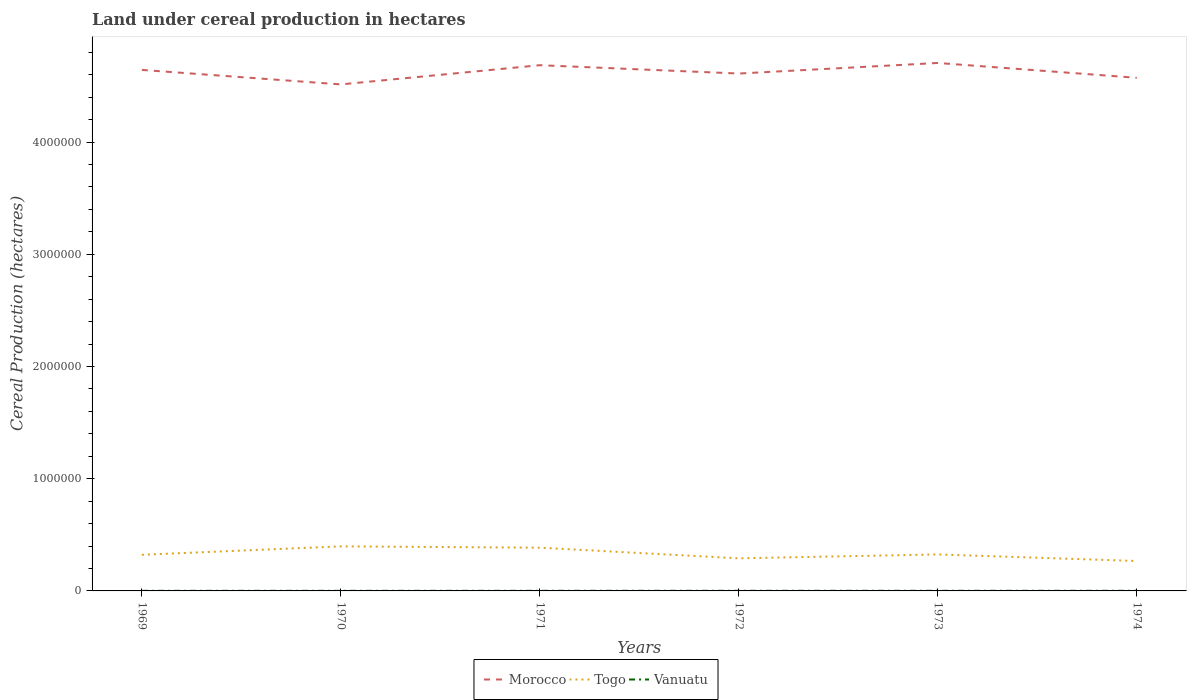How many different coloured lines are there?
Your answer should be compact. 3. Is the number of lines equal to the number of legend labels?
Keep it short and to the point. Yes. Across all years, what is the maximum land under cereal production in Togo?
Provide a succinct answer. 2.67e+05. In which year was the land under cereal production in Morocco maximum?
Keep it short and to the point. 1970. What is the total land under cereal production in Vanuatu in the graph?
Provide a succinct answer. -100. What is the difference between the highest and the second highest land under cereal production in Vanuatu?
Make the answer very short. 200. What is the difference between the highest and the lowest land under cereal production in Togo?
Offer a terse response. 2. What is the difference between two consecutive major ticks on the Y-axis?
Give a very brief answer. 1.00e+06. Are the values on the major ticks of Y-axis written in scientific E-notation?
Offer a very short reply. No. Does the graph contain any zero values?
Your answer should be compact. No. Does the graph contain grids?
Give a very brief answer. No. What is the title of the graph?
Ensure brevity in your answer.  Land under cereal production in hectares. Does "St. Martin (French part)" appear as one of the legend labels in the graph?
Offer a very short reply. No. What is the label or title of the X-axis?
Your answer should be compact. Years. What is the label or title of the Y-axis?
Offer a terse response. Cereal Production (hectares). What is the Cereal Production (hectares) in Morocco in 1969?
Give a very brief answer. 4.64e+06. What is the Cereal Production (hectares) of Togo in 1969?
Keep it short and to the point. 3.22e+05. What is the Cereal Production (hectares) of Vanuatu in 1969?
Offer a terse response. 800. What is the Cereal Production (hectares) of Morocco in 1970?
Keep it short and to the point. 4.51e+06. What is the Cereal Production (hectares) in Togo in 1970?
Your answer should be compact. 3.97e+05. What is the Cereal Production (hectares) of Vanuatu in 1970?
Your answer should be compact. 850. What is the Cereal Production (hectares) of Morocco in 1971?
Provide a succinct answer. 4.68e+06. What is the Cereal Production (hectares) of Togo in 1971?
Offer a very short reply. 3.85e+05. What is the Cereal Production (hectares) in Vanuatu in 1971?
Your answer should be very brief. 900. What is the Cereal Production (hectares) of Morocco in 1972?
Keep it short and to the point. 4.61e+06. What is the Cereal Production (hectares) of Togo in 1972?
Keep it short and to the point. 2.90e+05. What is the Cereal Production (hectares) of Vanuatu in 1972?
Provide a short and direct response. 950. What is the Cereal Production (hectares) in Morocco in 1973?
Your answer should be compact. 4.70e+06. What is the Cereal Production (hectares) of Togo in 1973?
Offer a very short reply. 3.25e+05. What is the Cereal Production (hectares) in Vanuatu in 1973?
Offer a terse response. 1000. What is the Cereal Production (hectares) in Morocco in 1974?
Offer a terse response. 4.57e+06. What is the Cereal Production (hectares) of Togo in 1974?
Provide a succinct answer. 2.67e+05. What is the Cereal Production (hectares) of Vanuatu in 1974?
Your answer should be very brief. 1000. Across all years, what is the maximum Cereal Production (hectares) in Morocco?
Your response must be concise. 4.70e+06. Across all years, what is the maximum Cereal Production (hectares) of Togo?
Offer a very short reply. 3.97e+05. Across all years, what is the maximum Cereal Production (hectares) in Vanuatu?
Your answer should be very brief. 1000. Across all years, what is the minimum Cereal Production (hectares) in Morocco?
Provide a succinct answer. 4.51e+06. Across all years, what is the minimum Cereal Production (hectares) of Togo?
Ensure brevity in your answer.  2.67e+05. Across all years, what is the minimum Cereal Production (hectares) in Vanuatu?
Make the answer very short. 800. What is the total Cereal Production (hectares) of Morocco in the graph?
Provide a succinct answer. 2.77e+07. What is the total Cereal Production (hectares) of Togo in the graph?
Your answer should be compact. 1.99e+06. What is the total Cereal Production (hectares) of Vanuatu in the graph?
Your response must be concise. 5500. What is the difference between the Cereal Production (hectares) of Morocco in 1969 and that in 1970?
Your answer should be compact. 1.29e+05. What is the difference between the Cereal Production (hectares) of Togo in 1969 and that in 1970?
Your answer should be compact. -7.50e+04. What is the difference between the Cereal Production (hectares) in Vanuatu in 1969 and that in 1970?
Provide a succinct answer. -50. What is the difference between the Cereal Production (hectares) in Morocco in 1969 and that in 1971?
Offer a terse response. -4.19e+04. What is the difference between the Cereal Production (hectares) of Togo in 1969 and that in 1971?
Give a very brief answer. -6.33e+04. What is the difference between the Cereal Production (hectares) of Vanuatu in 1969 and that in 1971?
Provide a short and direct response. -100. What is the difference between the Cereal Production (hectares) of Morocco in 1969 and that in 1972?
Provide a succinct answer. 3.23e+04. What is the difference between the Cereal Production (hectares) in Togo in 1969 and that in 1972?
Make the answer very short. 3.15e+04. What is the difference between the Cereal Production (hectares) in Vanuatu in 1969 and that in 1972?
Keep it short and to the point. -150. What is the difference between the Cereal Production (hectares) in Morocco in 1969 and that in 1973?
Offer a very short reply. -6.18e+04. What is the difference between the Cereal Production (hectares) of Togo in 1969 and that in 1973?
Offer a very short reply. -3030. What is the difference between the Cereal Production (hectares) in Vanuatu in 1969 and that in 1973?
Provide a succinct answer. -200. What is the difference between the Cereal Production (hectares) of Morocco in 1969 and that in 1974?
Offer a terse response. 7.04e+04. What is the difference between the Cereal Production (hectares) of Togo in 1969 and that in 1974?
Provide a succinct answer. 5.53e+04. What is the difference between the Cereal Production (hectares) in Vanuatu in 1969 and that in 1974?
Provide a succinct answer. -200. What is the difference between the Cereal Production (hectares) of Morocco in 1970 and that in 1971?
Give a very brief answer. -1.71e+05. What is the difference between the Cereal Production (hectares) in Togo in 1970 and that in 1971?
Offer a very short reply. 1.17e+04. What is the difference between the Cereal Production (hectares) in Vanuatu in 1970 and that in 1971?
Provide a succinct answer. -50. What is the difference between the Cereal Production (hectares) of Morocco in 1970 and that in 1972?
Provide a short and direct response. -9.69e+04. What is the difference between the Cereal Production (hectares) in Togo in 1970 and that in 1972?
Make the answer very short. 1.07e+05. What is the difference between the Cereal Production (hectares) in Vanuatu in 1970 and that in 1972?
Your answer should be very brief. -100. What is the difference between the Cereal Production (hectares) of Morocco in 1970 and that in 1973?
Keep it short and to the point. -1.91e+05. What is the difference between the Cereal Production (hectares) of Togo in 1970 and that in 1973?
Offer a very short reply. 7.20e+04. What is the difference between the Cereal Production (hectares) of Vanuatu in 1970 and that in 1973?
Give a very brief answer. -150. What is the difference between the Cereal Production (hectares) of Morocco in 1970 and that in 1974?
Give a very brief answer. -5.88e+04. What is the difference between the Cereal Production (hectares) in Togo in 1970 and that in 1974?
Provide a short and direct response. 1.30e+05. What is the difference between the Cereal Production (hectares) of Vanuatu in 1970 and that in 1974?
Offer a terse response. -150. What is the difference between the Cereal Production (hectares) of Morocco in 1971 and that in 1972?
Offer a very short reply. 7.42e+04. What is the difference between the Cereal Production (hectares) of Togo in 1971 and that in 1972?
Your answer should be very brief. 9.48e+04. What is the difference between the Cereal Production (hectares) of Morocco in 1971 and that in 1973?
Your response must be concise. -1.99e+04. What is the difference between the Cereal Production (hectares) of Togo in 1971 and that in 1973?
Ensure brevity in your answer.  6.03e+04. What is the difference between the Cereal Production (hectares) of Vanuatu in 1971 and that in 1973?
Offer a very short reply. -100. What is the difference between the Cereal Production (hectares) in Morocco in 1971 and that in 1974?
Give a very brief answer. 1.12e+05. What is the difference between the Cereal Production (hectares) in Togo in 1971 and that in 1974?
Give a very brief answer. 1.19e+05. What is the difference between the Cereal Production (hectares) in Vanuatu in 1971 and that in 1974?
Keep it short and to the point. -100. What is the difference between the Cereal Production (hectares) in Morocco in 1972 and that in 1973?
Offer a very short reply. -9.41e+04. What is the difference between the Cereal Production (hectares) of Togo in 1972 and that in 1973?
Provide a short and direct response. -3.45e+04. What is the difference between the Cereal Production (hectares) of Vanuatu in 1972 and that in 1973?
Provide a succinct answer. -50. What is the difference between the Cereal Production (hectares) of Morocco in 1972 and that in 1974?
Offer a terse response. 3.81e+04. What is the difference between the Cereal Production (hectares) of Togo in 1972 and that in 1974?
Your answer should be compact. 2.38e+04. What is the difference between the Cereal Production (hectares) of Vanuatu in 1972 and that in 1974?
Your response must be concise. -50. What is the difference between the Cereal Production (hectares) in Morocco in 1973 and that in 1974?
Make the answer very short. 1.32e+05. What is the difference between the Cereal Production (hectares) in Togo in 1973 and that in 1974?
Provide a short and direct response. 5.84e+04. What is the difference between the Cereal Production (hectares) in Morocco in 1969 and the Cereal Production (hectares) in Togo in 1970?
Offer a terse response. 4.25e+06. What is the difference between the Cereal Production (hectares) in Morocco in 1969 and the Cereal Production (hectares) in Vanuatu in 1970?
Provide a succinct answer. 4.64e+06. What is the difference between the Cereal Production (hectares) in Togo in 1969 and the Cereal Production (hectares) in Vanuatu in 1970?
Ensure brevity in your answer.  3.21e+05. What is the difference between the Cereal Production (hectares) of Morocco in 1969 and the Cereal Production (hectares) of Togo in 1971?
Ensure brevity in your answer.  4.26e+06. What is the difference between the Cereal Production (hectares) of Morocco in 1969 and the Cereal Production (hectares) of Vanuatu in 1971?
Offer a terse response. 4.64e+06. What is the difference between the Cereal Production (hectares) of Togo in 1969 and the Cereal Production (hectares) of Vanuatu in 1971?
Keep it short and to the point. 3.21e+05. What is the difference between the Cereal Production (hectares) of Morocco in 1969 and the Cereal Production (hectares) of Togo in 1972?
Ensure brevity in your answer.  4.35e+06. What is the difference between the Cereal Production (hectares) in Morocco in 1969 and the Cereal Production (hectares) in Vanuatu in 1972?
Make the answer very short. 4.64e+06. What is the difference between the Cereal Production (hectares) of Togo in 1969 and the Cereal Production (hectares) of Vanuatu in 1972?
Keep it short and to the point. 3.21e+05. What is the difference between the Cereal Production (hectares) of Morocco in 1969 and the Cereal Production (hectares) of Togo in 1973?
Your answer should be very brief. 4.32e+06. What is the difference between the Cereal Production (hectares) in Morocco in 1969 and the Cereal Production (hectares) in Vanuatu in 1973?
Provide a short and direct response. 4.64e+06. What is the difference between the Cereal Production (hectares) of Togo in 1969 and the Cereal Production (hectares) of Vanuatu in 1973?
Provide a succinct answer. 3.21e+05. What is the difference between the Cereal Production (hectares) in Morocco in 1969 and the Cereal Production (hectares) in Togo in 1974?
Provide a succinct answer. 4.38e+06. What is the difference between the Cereal Production (hectares) of Morocco in 1969 and the Cereal Production (hectares) of Vanuatu in 1974?
Provide a succinct answer. 4.64e+06. What is the difference between the Cereal Production (hectares) in Togo in 1969 and the Cereal Production (hectares) in Vanuatu in 1974?
Provide a short and direct response. 3.21e+05. What is the difference between the Cereal Production (hectares) of Morocco in 1970 and the Cereal Production (hectares) of Togo in 1971?
Make the answer very short. 4.13e+06. What is the difference between the Cereal Production (hectares) in Morocco in 1970 and the Cereal Production (hectares) in Vanuatu in 1971?
Your answer should be compact. 4.51e+06. What is the difference between the Cereal Production (hectares) of Togo in 1970 and the Cereal Production (hectares) of Vanuatu in 1971?
Offer a very short reply. 3.96e+05. What is the difference between the Cereal Production (hectares) in Morocco in 1970 and the Cereal Production (hectares) in Togo in 1972?
Provide a succinct answer. 4.22e+06. What is the difference between the Cereal Production (hectares) in Morocco in 1970 and the Cereal Production (hectares) in Vanuatu in 1972?
Your answer should be very brief. 4.51e+06. What is the difference between the Cereal Production (hectares) of Togo in 1970 and the Cereal Production (hectares) of Vanuatu in 1972?
Keep it short and to the point. 3.96e+05. What is the difference between the Cereal Production (hectares) in Morocco in 1970 and the Cereal Production (hectares) in Togo in 1973?
Your answer should be very brief. 4.19e+06. What is the difference between the Cereal Production (hectares) in Morocco in 1970 and the Cereal Production (hectares) in Vanuatu in 1973?
Provide a short and direct response. 4.51e+06. What is the difference between the Cereal Production (hectares) of Togo in 1970 and the Cereal Production (hectares) of Vanuatu in 1973?
Offer a very short reply. 3.96e+05. What is the difference between the Cereal Production (hectares) in Morocco in 1970 and the Cereal Production (hectares) in Togo in 1974?
Offer a very short reply. 4.25e+06. What is the difference between the Cereal Production (hectares) of Morocco in 1970 and the Cereal Production (hectares) of Vanuatu in 1974?
Provide a succinct answer. 4.51e+06. What is the difference between the Cereal Production (hectares) of Togo in 1970 and the Cereal Production (hectares) of Vanuatu in 1974?
Make the answer very short. 3.96e+05. What is the difference between the Cereal Production (hectares) of Morocco in 1971 and the Cereal Production (hectares) of Togo in 1972?
Your answer should be compact. 4.39e+06. What is the difference between the Cereal Production (hectares) in Morocco in 1971 and the Cereal Production (hectares) in Vanuatu in 1972?
Your response must be concise. 4.68e+06. What is the difference between the Cereal Production (hectares) in Togo in 1971 and the Cereal Production (hectares) in Vanuatu in 1972?
Make the answer very short. 3.84e+05. What is the difference between the Cereal Production (hectares) in Morocco in 1971 and the Cereal Production (hectares) in Togo in 1973?
Give a very brief answer. 4.36e+06. What is the difference between the Cereal Production (hectares) of Morocco in 1971 and the Cereal Production (hectares) of Vanuatu in 1973?
Provide a short and direct response. 4.68e+06. What is the difference between the Cereal Production (hectares) in Togo in 1971 and the Cereal Production (hectares) in Vanuatu in 1973?
Offer a terse response. 3.84e+05. What is the difference between the Cereal Production (hectares) in Morocco in 1971 and the Cereal Production (hectares) in Togo in 1974?
Provide a short and direct response. 4.42e+06. What is the difference between the Cereal Production (hectares) in Morocco in 1971 and the Cereal Production (hectares) in Vanuatu in 1974?
Offer a very short reply. 4.68e+06. What is the difference between the Cereal Production (hectares) in Togo in 1971 and the Cereal Production (hectares) in Vanuatu in 1974?
Provide a short and direct response. 3.84e+05. What is the difference between the Cereal Production (hectares) in Morocco in 1972 and the Cereal Production (hectares) in Togo in 1973?
Your answer should be very brief. 4.29e+06. What is the difference between the Cereal Production (hectares) in Morocco in 1972 and the Cereal Production (hectares) in Vanuatu in 1973?
Make the answer very short. 4.61e+06. What is the difference between the Cereal Production (hectares) in Togo in 1972 and the Cereal Production (hectares) in Vanuatu in 1973?
Keep it short and to the point. 2.90e+05. What is the difference between the Cereal Production (hectares) of Morocco in 1972 and the Cereal Production (hectares) of Togo in 1974?
Give a very brief answer. 4.34e+06. What is the difference between the Cereal Production (hectares) in Morocco in 1972 and the Cereal Production (hectares) in Vanuatu in 1974?
Provide a succinct answer. 4.61e+06. What is the difference between the Cereal Production (hectares) in Togo in 1972 and the Cereal Production (hectares) in Vanuatu in 1974?
Your answer should be very brief. 2.90e+05. What is the difference between the Cereal Production (hectares) in Morocco in 1973 and the Cereal Production (hectares) in Togo in 1974?
Make the answer very short. 4.44e+06. What is the difference between the Cereal Production (hectares) of Morocco in 1973 and the Cereal Production (hectares) of Vanuatu in 1974?
Make the answer very short. 4.70e+06. What is the difference between the Cereal Production (hectares) in Togo in 1973 and the Cereal Production (hectares) in Vanuatu in 1974?
Give a very brief answer. 3.24e+05. What is the average Cereal Production (hectares) in Morocco per year?
Offer a terse response. 4.62e+06. What is the average Cereal Production (hectares) of Togo per year?
Offer a very short reply. 3.31e+05. What is the average Cereal Production (hectares) of Vanuatu per year?
Provide a short and direct response. 916.67. In the year 1969, what is the difference between the Cereal Production (hectares) of Morocco and Cereal Production (hectares) of Togo?
Your answer should be compact. 4.32e+06. In the year 1969, what is the difference between the Cereal Production (hectares) of Morocco and Cereal Production (hectares) of Vanuatu?
Make the answer very short. 4.64e+06. In the year 1969, what is the difference between the Cereal Production (hectares) in Togo and Cereal Production (hectares) in Vanuatu?
Offer a terse response. 3.21e+05. In the year 1970, what is the difference between the Cereal Production (hectares) of Morocco and Cereal Production (hectares) of Togo?
Offer a very short reply. 4.12e+06. In the year 1970, what is the difference between the Cereal Production (hectares) of Morocco and Cereal Production (hectares) of Vanuatu?
Offer a terse response. 4.51e+06. In the year 1970, what is the difference between the Cereal Production (hectares) in Togo and Cereal Production (hectares) in Vanuatu?
Offer a very short reply. 3.96e+05. In the year 1971, what is the difference between the Cereal Production (hectares) of Morocco and Cereal Production (hectares) of Togo?
Provide a succinct answer. 4.30e+06. In the year 1971, what is the difference between the Cereal Production (hectares) in Morocco and Cereal Production (hectares) in Vanuatu?
Your response must be concise. 4.68e+06. In the year 1971, what is the difference between the Cereal Production (hectares) of Togo and Cereal Production (hectares) of Vanuatu?
Keep it short and to the point. 3.84e+05. In the year 1972, what is the difference between the Cereal Production (hectares) in Morocco and Cereal Production (hectares) in Togo?
Offer a very short reply. 4.32e+06. In the year 1972, what is the difference between the Cereal Production (hectares) in Morocco and Cereal Production (hectares) in Vanuatu?
Provide a short and direct response. 4.61e+06. In the year 1972, what is the difference between the Cereal Production (hectares) in Togo and Cereal Production (hectares) in Vanuatu?
Offer a terse response. 2.90e+05. In the year 1973, what is the difference between the Cereal Production (hectares) of Morocco and Cereal Production (hectares) of Togo?
Provide a succinct answer. 4.38e+06. In the year 1973, what is the difference between the Cereal Production (hectares) in Morocco and Cereal Production (hectares) in Vanuatu?
Provide a succinct answer. 4.70e+06. In the year 1973, what is the difference between the Cereal Production (hectares) in Togo and Cereal Production (hectares) in Vanuatu?
Offer a very short reply. 3.24e+05. In the year 1974, what is the difference between the Cereal Production (hectares) in Morocco and Cereal Production (hectares) in Togo?
Your answer should be very brief. 4.31e+06. In the year 1974, what is the difference between the Cereal Production (hectares) in Morocco and Cereal Production (hectares) in Vanuatu?
Keep it short and to the point. 4.57e+06. In the year 1974, what is the difference between the Cereal Production (hectares) in Togo and Cereal Production (hectares) in Vanuatu?
Provide a short and direct response. 2.66e+05. What is the ratio of the Cereal Production (hectares) in Morocco in 1969 to that in 1970?
Your response must be concise. 1.03. What is the ratio of the Cereal Production (hectares) of Togo in 1969 to that in 1970?
Your answer should be compact. 0.81. What is the ratio of the Cereal Production (hectares) of Vanuatu in 1969 to that in 1970?
Make the answer very short. 0.94. What is the ratio of the Cereal Production (hectares) of Togo in 1969 to that in 1971?
Your answer should be compact. 0.84. What is the ratio of the Cereal Production (hectares) in Togo in 1969 to that in 1972?
Make the answer very short. 1.11. What is the ratio of the Cereal Production (hectares) of Vanuatu in 1969 to that in 1972?
Your answer should be compact. 0.84. What is the ratio of the Cereal Production (hectares) in Morocco in 1969 to that in 1973?
Offer a very short reply. 0.99. What is the ratio of the Cereal Production (hectares) in Togo in 1969 to that in 1973?
Keep it short and to the point. 0.99. What is the ratio of the Cereal Production (hectares) in Morocco in 1969 to that in 1974?
Your answer should be very brief. 1.02. What is the ratio of the Cereal Production (hectares) in Togo in 1969 to that in 1974?
Keep it short and to the point. 1.21. What is the ratio of the Cereal Production (hectares) of Morocco in 1970 to that in 1971?
Keep it short and to the point. 0.96. What is the ratio of the Cereal Production (hectares) in Togo in 1970 to that in 1971?
Make the answer very short. 1.03. What is the ratio of the Cereal Production (hectares) in Vanuatu in 1970 to that in 1971?
Your answer should be very brief. 0.94. What is the ratio of the Cereal Production (hectares) of Togo in 1970 to that in 1972?
Offer a very short reply. 1.37. What is the ratio of the Cereal Production (hectares) of Vanuatu in 1970 to that in 1972?
Your answer should be compact. 0.89. What is the ratio of the Cereal Production (hectares) of Morocco in 1970 to that in 1973?
Keep it short and to the point. 0.96. What is the ratio of the Cereal Production (hectares) of Togo in 1970 to that in 1973?
Give a very brief answer. 1.22. What is the ratio of the Cereal Production (hectares) of Morocco in 1970 to that in 1974?
Make the answer very short. 0.99. What is the ratio of the Cereal Production (hectares) in Togo in 1970 to that in 1974?
Keep it short and to the point. 1.49. What is the ratio of the Cereal Production (hectares) in Morocco in 1971 to that in 1972?
Your answer should be compact. 1.02. What is the ratio of the Cereal Production (hectares) in Togo in 1971 to that in 1972?
Make the answer very short. 1.33. What is the ratio of the Cereal Production (hectares) in Vanuatu in 1971 to that in 1972?
Your response must be concise. 0.95. What is the ratio of the Cereal Production (hectares) in Togo in 1971 to that in 1973?
Keep it short and to the point. 1.19. What is the ratio of the Cereal Production (hectares) in Vanuatu in 1971 to that in 1973?
Provide a short and direct response. 0.9. What is the ratio of the Cereal Production (hectares) in Morocco in 1971 to that in 1974?
Your answer should be compact. 1.02. What is the ratio of the Cereal Production (hectares) in Togo in 1971 to that in 1974?
Keep it short and to the point. 1.44. What is the ratio of the Cereal Production (hectares) of Vanuatu in 1971 to that in 1974?
Provide a succinct answer. 0.9. What is the ratio of the Cereal Production (hectares) of Morocco in 1972 to that in 1973?
Your answer should be compact. 0.98. What is the ratio of the Cereal Production (hectares) in Togo in 1972 to that in 1973?
Your response must be concise. 0.89. What is the ratio of the Cereal Production (hectares) of Vanuatu in 1972 to that in 1973?
Make the answer very short. 0.95. What is the ratio of the Cereal Production (hectares) of Morocco in 1972 to that in 1974?
Provide a succinct answer. 1.01. What is the ratio of the Cereal Production (hectares) of Togo in 1972 to that in 1974?
Offer a terse response. 1.09. What is the ratio of the Cereal Production (hectares) in Vanuatu in 1972 to that in 1974?
Provide a short and direct response. 0.95. What is the ratio of the Cereal Production (hectares) in Morocco in 1973 to that in 1974?
Give a very brief answer. 1.03. What is the ratio of the Cereal Production (hectares) of Togo in 1973 to that in 1974?
Offer a terse response. 1.22. What is the ratio of the Cereal Production (hectares) of Vanuatu in 1973 to that in 1974?
Your response must be concise. 1. What is the difference between the highest and the second highest Cereal Production (hectares) of Morocco?
Your response must be concise. 1.99e+04. What is the difference between the highest and the second highest Cereal Production (hectares) of Togo?
Provide a succinct answer. 1.17e+04. What is the difference between the highest and the second highest Cereal Production (hectares) in Vanuatu?
Provide a succinct answer. 0. What is the difference between the highest and the lowest Cereal Production (hectares) of Morocco?
Keep it short and to the point. 1.91e+05. What is the difference between the highest and the lowest Cereal Production (hectares) of Togo?
Keep it short and to the point. 1.30e+05. What is the difference between the highest and the lowest Cereal Production (hectares) in Vanuatu?
Make the answer very short. 200. 